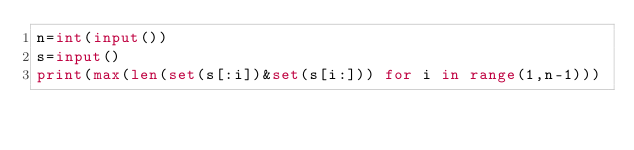<code> <loc_0><loc_0><loc_500><loc_500><_Python_>n=int(input())
s=input()
print(max(len(set(s[:i])&set(s[i:])) for i in range(1,n-1)))</code> 